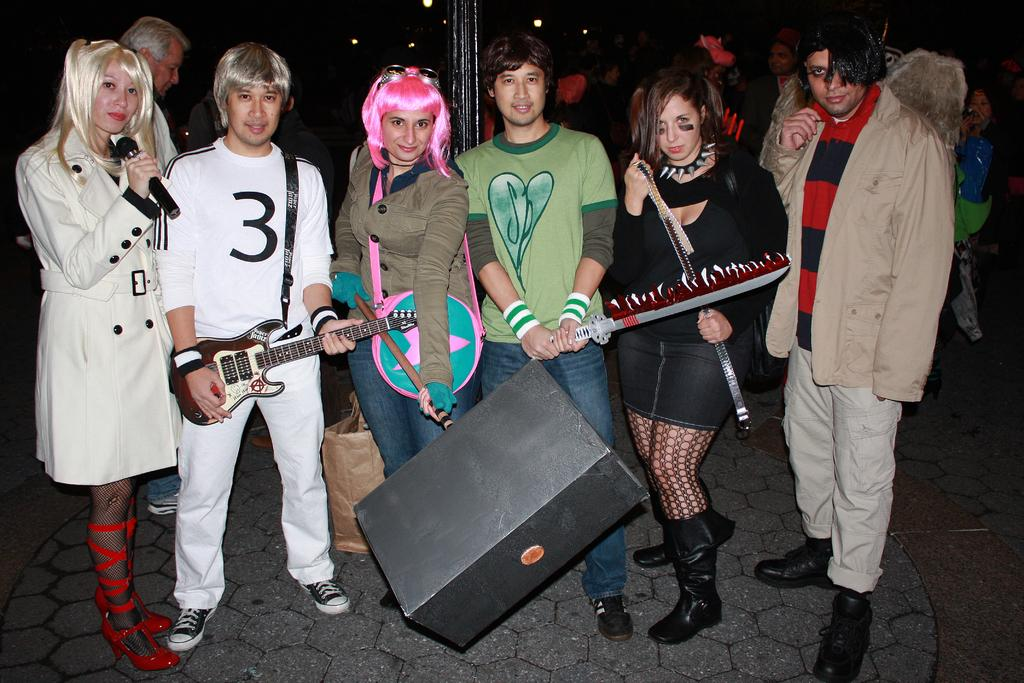What is the main subject of the image? The main subject of the image is a group of people. What are the people in the image doing? The people are holding objects in their hands. What type of kettle can be seen in the image? There is no kettle present in the image. What part of the brain is visible in the image? There is no brain visible in the image. 